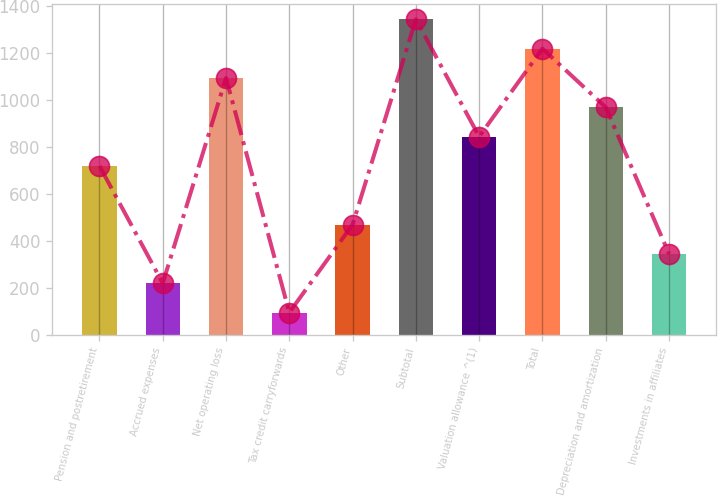<chart> <loc_0><loc_0><loc_500><loc_500><bar_chart><fcel>Pension and postretirement<fcel>Accrued expenses<fcel>Net operating loss<fcel>Tax credit carryforwards<fcel>Other<fcel>Subtotal<fcel>Valuation allowance ^(1)<fcel>Total<fcel>Depreciation and amortization<fcel>Investments in affiliates<nl><fcel>719.5<fcel>219.1<fcel>1094.8<fcel>94<fcel>469.3<fcel>1345<fcel>844.6<fcel>1219.9<fcel>969.7<fcel>344.2<nl></chart> 